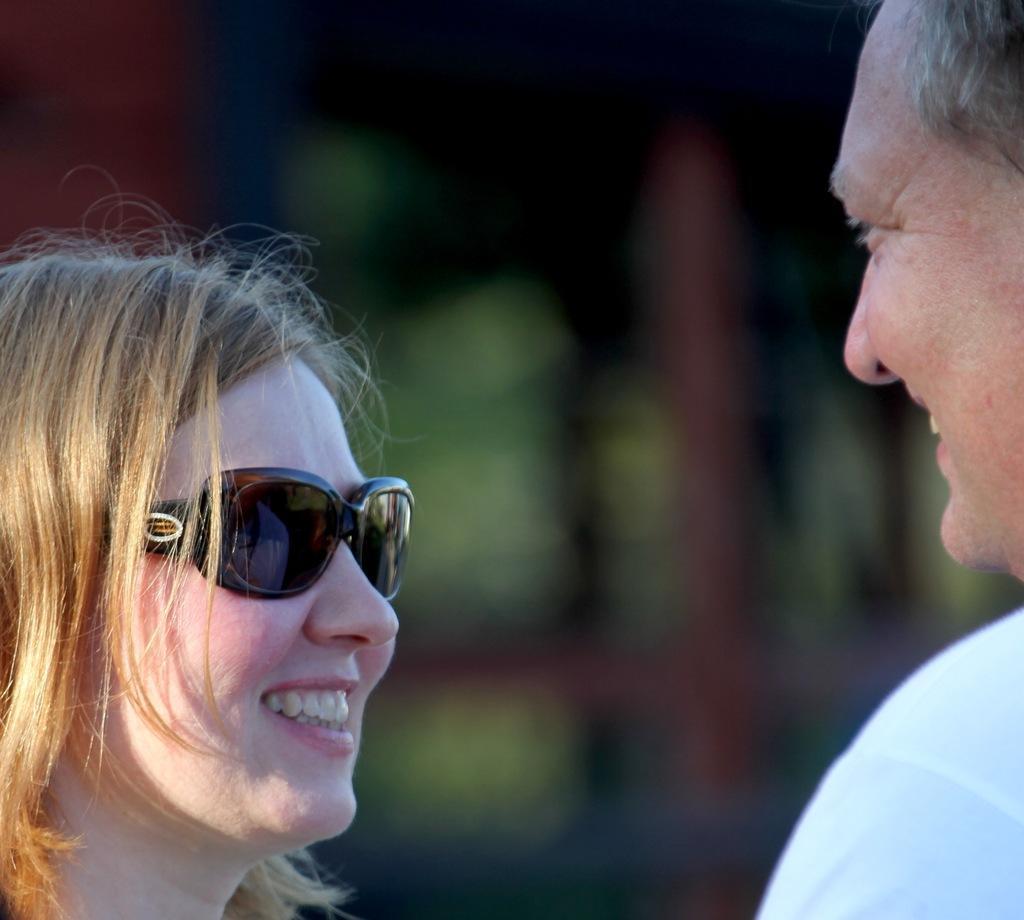Can you describe this image briefly? In the foreground of the picture we can see a man and a woman. The background is blurred. 